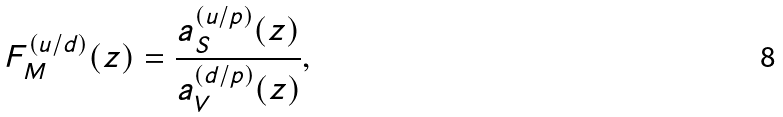Convert formula to latex. <formula><loc_0><loc_0><loc_500><loc_500>F _ { M } ^ { ( u / d ) } ( z ) = \frac { a _ { S } ^ { ( u / p ) } ( z ) } { a _ { V } ^ { ( d / p ) } ( z ) } ,</formula> 